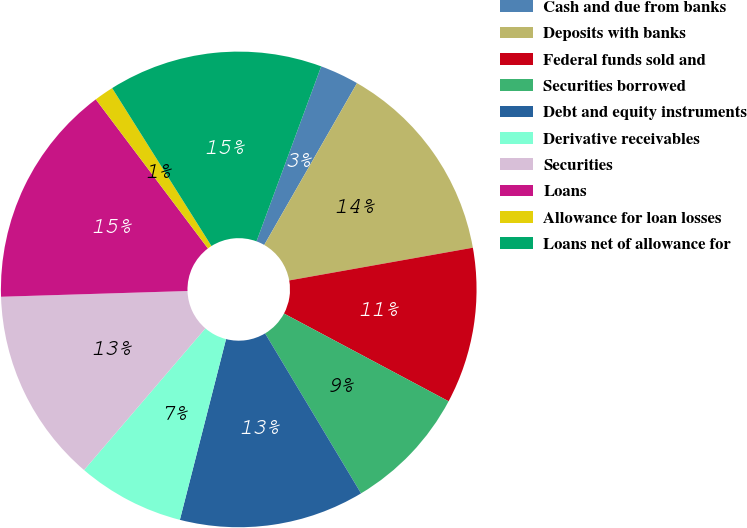Convert chart. <chart><loc_0><loc_0><loc_500><loc_500><pie_chart><fcel>Cash and due from banks<fcel>Deposits with banks<fcel>Federal funds sold and<fcel>Securities borrowed<fcel>Debt and equity instruments<fcel>Derivative receivables<fcel>Securities<fcel>Loans<fcel>Allowance for loan losses<fcel>Loans net of allowance for<nl><fcel>2.65%<fcel>13.91%<fcel>10.6%<fcel>8.61%<fcel>12.58%<fcel>7.29%<fcel>13.24%<fcel>15.23%<fcel>1.33%<fcel>14.57%<nl></chart> 